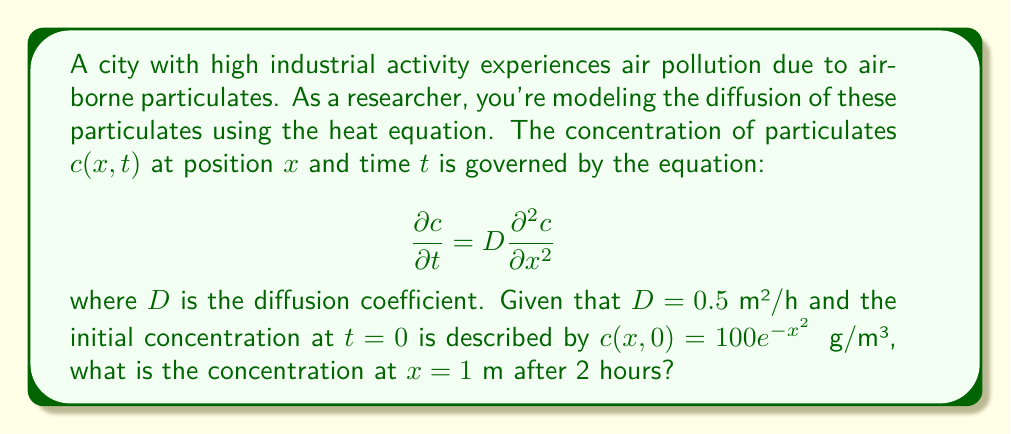What is the answer to this math problem? To solve this problem, we'll use the fundamental solution of the heat equation:

1) The general solution for the 1D heat equation with initial condition $c(x,0) = f(x)$ is:

   $$c(x,t) = \frac{1}{\sqrt{4\pi Dt}} \int_{-\infty}^{\infty} f(\xi) e^{-\frac{(x-\xi)^2}{4Dt}} d\xi$$

2) In our case, $f(x) = 100e^{-x^2}$, $D = 0.5$ m²/h, $t = 2$ h, and we want to find $c(1,2)$.

3) Substituting these values:

   $$c(1,2) = \frac{1}{\sqrt{4\pi(0.5)(2)}} \int_{-\infty}^{\infty} 100e^{-\xi^2} e^{-\frac{(1-\xi)^2}{4(0.5)(2)}} d\xi$$

4) Simplify:

   $$c(1,2) = \frac{100}{\sqrt{4\pi}} \int_{-\infty}^{\infty} e^{-\xi^2} e^{-\frac{(1-\xi)^2}{4}} d\xi$$

5) This integral can be evaluated to:

   $$c(1,2) = \frac{100}{\sqrt{5}} e^{-\frac{1}{5}} \approx 35.54$$

Therefore, the concentration at $x = 1$ m after 2 hours is approximately 35.54 μg/m³.
Answer: 35.54 μg/m³ 